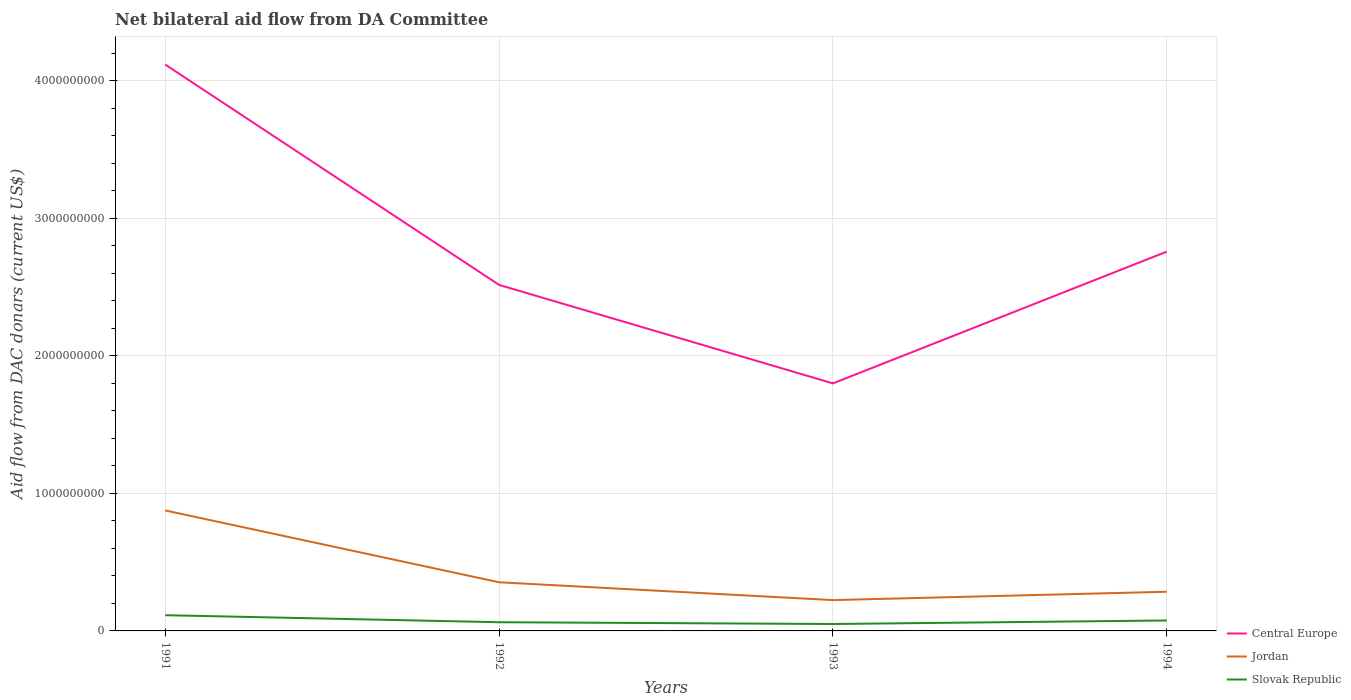How many different coloured lines are there?
Offer a very short reply. 3. Does the line corresponding to Central Europe intersect with the line corresponding to Slovak Republic?
Make the answer very short. No. Across all years, what is the maximum aid flow in in Central Europe?
Offer a very short reply. 1.80e+09. In which year was the aid flow in in Central Europe maximum?
Give a very brief answer. 1993. What is the total aid flow in in Jordan in the graph?
Provide a succinct answer. 5.22e+08. What is the difference between the highest and the second highest aid flow in in Central Europe?
Provide a succinct answer. 2.32e+09. Is the aid flow in in Slovak Republic strictly greater than the aid flow in in Central Europe over the years?
Your answer should be very brief. Yes. What is the difference between two consecutive major ticks on the Y-axis?
Ensure brevity in your answer.  1.00e+09. Are the values on the major ticks of Y-axis written in scientific E-notation?
Your response must be concise. No. Does the graph contain any zero values?
Your response must be concise. No. Does the graph contain grids?
Give a very brief answer. Yes. Where does the legend appear in the graph?
Give a very brief answer. Bottom right. How many legend labels are there?
Ensure brevity in your answer.  3. What is the title of the graph?
Ensure brevity in your answer.  Net bilateral aid flow from DA Committee. Does "Liechtenstein" appear as one of the legend labels in the graph?
Keep it short and to the point. No. What is the label or title of the Y-axis?
Offer a terse response. Aid flow from DAC donars (current US$). What is the Aid flow from DAC donars (current US$) in Central Europe in 1991?
Make the answer very short. 4.12e+09. What is the Aid flow from DAC donars (current US$) in Jordan in 1991?
Keep it short and to the point. 8.76e+08. What is the Aid flow from DAC donars (current US$) of Slovak Republic in 1991?
Your answer should be very brief. 1.14e+08. What is the Aid flow from DAC donars (current US$) of Central Europe in 1992?
Your response must be concise. 2.52e+09. What is the Aid flow from DAC donars (current US$) of Jordan in 1992?
Give a very brief answer. 3.54e+08. What is the Aid flow from DAC donars (current US$) of Slovak Republic in 1992?
Your response must be concise. 6.32e+07. What is the Aid flow from DAC donars (current US$) of Central Europe in 1993?
Ensure brevity in your answer.  1.80e+09. What is the Aid flow from DAC donars (current US$) of Jordan in 1993?
Keep it short and to the point. 2.24e+08. What is the Aid flow from DAC donars (current US$) of Slovak Republic in 1993?
Keep it short and to the point. 5.03e+07. What is the Aid flow from DAC donars (current US$) of Central Europe in 1994?
Your answer should be compact. 2.76e+09. What is the Aid flow from DAC donars (current US$) in Jordan in 1994?
Offer a terse response. 2.85e+08. What is the Aid flow from DAC donars (current US$) in Slovak Republic in 1994?
Provide a short and direct response. 7.60e+07. Across all years, what is the maximum Aid flow from DAC donars (current US$) in Central Europe?
Your answer should be very brief. 4.12e+09. Across all years, what is the maximum Aid flow from DAC donars (current US$) in Jordan?
Keep it short and to the point. 8.76e+08. Across all years, what is the maximum Aid flow from DAC donars (current US$) in Slovak Republic?
Offer a very short reply. 1.14e+08. Across all years, what is the minimum Aid flow from DAC donars (current US$) in Central Europe?
Ensure brevity in your answer.  1.80e+09. Across all years, what is the minimum Aid flow from DAC donars (current US$) of Jordan?
Make the answer very short. 2.24e+08. Across all years, what is the minimum Aid flow from DAC donars (current US$) of Slovak Republic?
Your response must be concise. 5.03e+07. What is the total Aid flow from DAC donars (current US$) in Central Europe in the graph?
Provide a short and direct response. 1.12e+1. What is the total Aid flow from DAC donars (current US$) of Jordan in the graph?
Ensure brevity in your answer.  1.74e+09. What is the total Aid flow from DAC donars (current US$) in Slovak Republic in the graph?
Keep it short and to the point. 3.04e+08. What is the difference between the Aid flow from DAC donars (current US$) of Central Europe in 1991 and that in 1992?
Offer a very short reply. 1.60e+09. What is the difference between the Aid flow from DAC donars (current US$) in Jordan in 1991 and that in 1992?
Your answer should be compact. 5.22e+08. What is the difference between the Aid flow from DAC donars (current US$) of Slovak Republic in 1991 and that in 1992?
Offer a very short reply. 5.11e+07. What is the difference between the Aid flow from DAC donars (current US$) of Central Europe in 1991 and that in 1993?
Give a very brief answer. 2.32e+09. What is the difference between the Aid flow from DAC donars (current US$) in Jordan in 1991 and that in 1993?
Provide a short and direct response. 6.52e+08. What is the difference between the Aid flow from DAC donars (current US$) of Slovak Republic in 1991 and that in 1993?
Provide a succinct answer. 6.40e+07. What is the difference between the Aid flow from DAC donars (current US$) of Central Europe in 1991 and that in 1994?
Make the answer very short. 1.36e+09. What is the difference between the Aid flow from DAC donars (current US$) of Jordan in 1991 and that in 1994?
Provide a succinct answer. 5.91e+08. What is the difference between the Aid flow from DAC donars (current US$) in Slovak Republic in 1991 and that in 1994?
Offer a very short reply. 3.83e+07. What is the difference between the Aid flow from DAC donars (current US$) of Central Europe in 1992 and that in 1993?
Provide a succinct answer. 7.16e+08. What is the difference between the Aid flow from DAC donars (current US$) of Jordan in 1992 and that in 1993?
Offer a very short reply. 1.30e+08. What is the difference between the Aid flow from DAC donars (current US$) in Slovak Republic in 1992 and that in 1993?
Give a very brief answer. 1.29e+07. What is the difference between the Aid flow from DAC donars (current US$) in Central Europe in 1992 and that in 1994?
Give a very brief answer. -2.42e+08. What is the difference between the Aid flow from DAC donars (current US$) in Jordan in 1992 and that in 1994?
Give a very brief answer. 6.90e+07. What is the difference between the Aid flow from DAC donars (current US$) in Slovak Republic in 1992 and that in 1994?
Keep it short and to the point. -1.28e+07. What is the difference between the Aid flow from DAC donars (current US$) of Central Europe in 1993 and that in 1994?
Offer a terse response. -9.58e+08. What is the difference between the Aid flow from DAC donars (current US$) of Jordan in 1993 and that in 1994?
Ensure brevity in your answer.  -6.06e+07. What is the difference between the Aid flow from DAC donars (current US$) in Slovak Republic in 1993 and that in 1994?
Offer a terse response. -2.57e+07. What is the difference between the Aid flow from DAC donars (current US$) of Central Europe in 1991 and the Aid flow from DAC donars (current US$) of Jordan in 1992?
Provide a succinct answer. 3.76e+09. What is the difference between the Aid flow from DAC donars (current US$) of Central Europe in 1991 and the Aid flow from DAC donars (current US$) of Slovak Republic in 1992?
Provide a succinct answer. 4.05e+09. What is the difference between the Aid flow from DAC donars (current US$) in Jordan in 1991 and the Aid flow from DAC donars (current US$) in Slovak Republic in 1992?
Provide a succinct answer. 8.13e+08. What is the difference between the Aid flow from DAC donars (current US$) of Central Europe in 1991 and the Aid flow from DAC donars (current US$) of Jordan in 1993?
Offer a terse response. 3.89e+09. What is the difference between the Aid flow from DAC donars (current US$) of Central Europe in 1991 and the Aid flow from DAC donars (current US$) of Slovak Republic in 1993?
Make the answer very short. 4.07e+09. What is the difference between the Aid flow from DAC donars (current US$) in Jordan in 1991 and the Aid flow from DAC donars (current US$) in Slovak Republic in 1993?
Your answer should be very brief. 8.26e+08. What is the difference between the Aid flow from DAC donars (current US$) in Central Europe in 1991 and the Aid flow from DAC donars (current US$) in Jordan in 1994?
Your answer should be compact. 3.83e+09. What is the difference between the Aid flow from DAC donars (current US$) of Central Europe in 1991 and the Aid flow from DAC donars (current US$) of Slovak Republic in 1994?
Provide a short and direct response. 4.04e+09. What is the difference between the Aid flow from DAC donars (current US$) in Jordan in 1991 and the Aid flow from DAC donars (current US$) in Slovak Republic in 1994?
Offer a terse response. 8.00e+08. What is the difference between the Aid flow from DAC donars (current US$) of Central Europe in 1992 and the Aid flow from DAC donars (current US$) of Jordan in 1993?
Your response must be concise. 2.29e+09. What is the difference between the Aid flow from DAC donars (current US$) of Central Europe in 1992 and the Aid flow from DAC donars (current US$) of Slovak Republic in 1993?
Offer a very short reply. 2.47e+09. What is the difference between the Aid flow from DAC donars (current US$) in Jordan in 1992 and the Aid flow from DAC donars (current US$) in Slovak Republic in 1993?
Provide a succinct answer. 3.03e+08. What is the difference between the Aid flow from DAC donars (current US$) in Central Europe in 1992 and the Aid flow from DAC donars (current US$) in Jordan in 1994?
Offer a terse response. 2.23e+09. What is the difference between the Aid flow from DAC donars (current US$) in Central Europe in 1992 and the Aid flow from DAC donars (current US$) in Slovak Republic in 1994?
Your answer should be compact. 2.44e+09. What is the difference between the Aid flow from DAC donars (current US$) in Jordan in 1992 and the Aid flow from DAC donars (current US$) in Slovak Republic in 1994?
Offer a very short reply. 2.78e+08. What is the difference between the Aid flow from DAC donars (current US$) in Central Europe in 1993 and the Aid flow from DAC donars (current US$) in Jordan in 1994?
Offer a very short reply. 1.52e+09. What is the difference between the Aid flow from DAC donars (current US$) in Central Europe in 1993 and the Aid flow from DAC donars (current US$) in Slovak Republic in 1994?
Ensure brevity in your answer.  1.72e+09. What is the difference between the Aid flow from DAC donars (current US$) in Jordan in 1993 and the Aid flow from DAC donars (current US$) in Slovak Republic in 1994?
Provide a short and direct response. 1.48e+08. What is the average Aid flow from DAC donars (current US$) of Central Europe per year?
Provide a short and direct response. 2.80e+09. What is the average Aid flow from DAC donars (current US$) of Jordan per year?
Your answer should be compact. 4.35e+08. What is the average Aid flow from DAC donars (current US$) of Slovak Republic per year?
Keep it short and to the point. 7.60e+07. In the year 1991, what is the difference between the Aid flow from DAC donars (current US$) of Central Europe and Aid flow from DAC donars (current US$) of Jordan?
Keep it short and to the point. 3.24e+09. In the year 1991, what is the difference between the Aid flow from DAC donars (current US$) of Central Europe and Aid flow from DAC donars (current US$) of Slovak Republic?
Keep it short and to the point. 4.00e+09. In the year 1991, what is the difference between the Aid flow from DAC donars (current US$) in Jordan and Aid flow from DAC donars (current US$) in Slovak Republic?
Offer a terse response. 7.62e+08. In the year 1992, what is the difference between the Aid flow from DAC donars (current US$) of Central Europe and Aid flow from DAC donars (current US$) of Jordan?
Offer a terse response. 2.16e+09. In the year 1992, what is the difference between the Aid flow from DAC donars (current US$) in Central Europe and Aid flow from DAC donars (current US$) in Slovak Republic?
Provide a succinct answer. 2.45e+09. In the year 1992, what is the difference between the Aid flow from DAC donars (current US$) in Jordan and Aid flow from DAC donars (current US$) in Slovak Republic?
Make the answer very short. 2.90e+08. In the year 1993, what is the difference between the Aid flow from DAC donars (current US$) in Central Europe and Aid flow from DAC donars (current US$) in Jordan?
Make the answer very short. 1.58e+09. In the year 1993, what is the difference between the Aid flow from DAC donars (current US$) of Central Europe and Aid flow from DAC donars (current US$) of Slovak Republic?
Keep it short and to the point. 1.75e+09. In the year 1993, what is the difference between the Aid flow from DAC donars (current US$) in Jordan and Aid flow from DAC donars (current US$) in Slovak Republic?
Your answer should be very brief. 1.74e+08. In the year 1994, what is the difference between the Aid flow from DAC donars (current US$) in Central Europe and Aid flow from DAC donars (current US$) in Jordan?
Keep it short and to the point. 2.47e+09. In the year 1994, what is the difference between the Aid flow from DAC donars (current US$) of Central Europe and Aid flow from DAC donars (current US$) of Slovak Republic?
Offer a very short reply. 2.68e+09. In the year 1994, what is the difference between the Aid flow from DAC donars (current US$) of Jordan and Aid flow from DAC donars (current US$) of Slovak Republic?
Your response must be concise. 2.09e+08. What is the ratio of the Aid flow from DAC donars (current US$) in Central Europe in 1991 to that in 1992?
Your answer should be compact. 1.64. What is the ratio of the Aid flow from DAC donars (current US$) in Jordan in 1991 to that in 1992?
Your answer should be compact. 2.48. What is the ratio of the Aid flow from DAC donars (current US$) of Slovak Republic in 1991 to that in 1992?
Provide a short and direct response. 1.81. What is the ratio of the Aid flow from DAC donars (current US$) of Central Europe in 1991 to that in 1993?
Your answer should be very brief. 2.29. What is the ratio of the Aid flow from DAC donars (current US$) of Jordan in 1991 to that in 1993?
Your response must be concise. 3.91. What is the ratio of the Aid flow from DAC donars (current US$) of Slovak Republic in 1991 to that in 1993?
Provide a short and direct response. 2.27. What is the ratio of the Aid flow from DAC donars (current US$) of Central Europe in 1991 to that in 1994?
Ensure brevity in your answer.  1.49. What is the ratio of the Aid flow from DAC donars (current US$) of Jordan in 1991 to that in 1994?
Your response must be concise. 3.08. What is the ratio of the Aid flow from DAC donars (current US$) of Slovak Republic in 1991 to that in 1994?
Keep it short and to the point. 1.5. What is the ratio of the Aid flow from DAC donars (current US$) of Central Europe in 1992 to that in 1993?
Your answer should be compact. 1.4. What is the ratio of the Aid flow from DAC donars (current US$) in Jordan in 1992 to that in 1993?
Keep it short and to the point. 1.58. What is the ratio of the Aid flow from DAC donars (current US$) in Slovak Republic in 1992 to that in 1993?
Your answer should be very brief. 1.26. What is the ratio of the Aid flow from DAC donars (current US$) in Central Europe in 1992 to that in 1994?
Keep it short and to the point. 0.91. What is the ratio of the Aid flow from DAC donars (current US$) in Jordan in 1992 to that in 1994?
Offer a very short reply. 1.24. What is the ratio of the Aid flow from DAC donars (current US$) in Slovak Republic in 1992 to that in 1994?
Your answer should be very brief. 0.83. What is the ratio of the Aid flow from DAC donars (current US$) of Central Europe in 1993 to that in 1994?
Your answer should be very brief. 0.65. What is the ratio of the Aid flow from DAC donars (current US$) of Jordan in 1993 to that in 1994?
Keep it short and to the point. 0.79. What is the ratio of the Aid flow from DAC donars (current US$) of Slovak Republic in 1993 to that in 1994?
Ensure brevity in your answer.  0.66. What is the difference between the highest and the second highest Aid flow from DAC donars (current US$) of Central Europe?
Give a very brief answer. 1.36e+09. What is the difference between the highest and the second highest Aid flow from DAC donars (current US$) in Jordan?
Your answer should be compact. 5.22e+08. What is the difference between the highest and the second highest Aid flow from DAC donars (current US$) of Slovak Republic?
Provide a succinct answer. 3.83e+07. What is the difference between the highest and the lowest Aid flow from DAC donars (current US$) in Central Europe?
Your response must be concise. 2.32e+09. What is the difference between the highest and the lowest Aid flow from DAC donars (current US$) in Jordan?
Ensure brevity in your answer.  6.52e+08. What is the difference between the highest and the lowest Aid flow from DAC donars (current US$) of Slovak Republic?
Make the answer very short. 6.40e+07. 